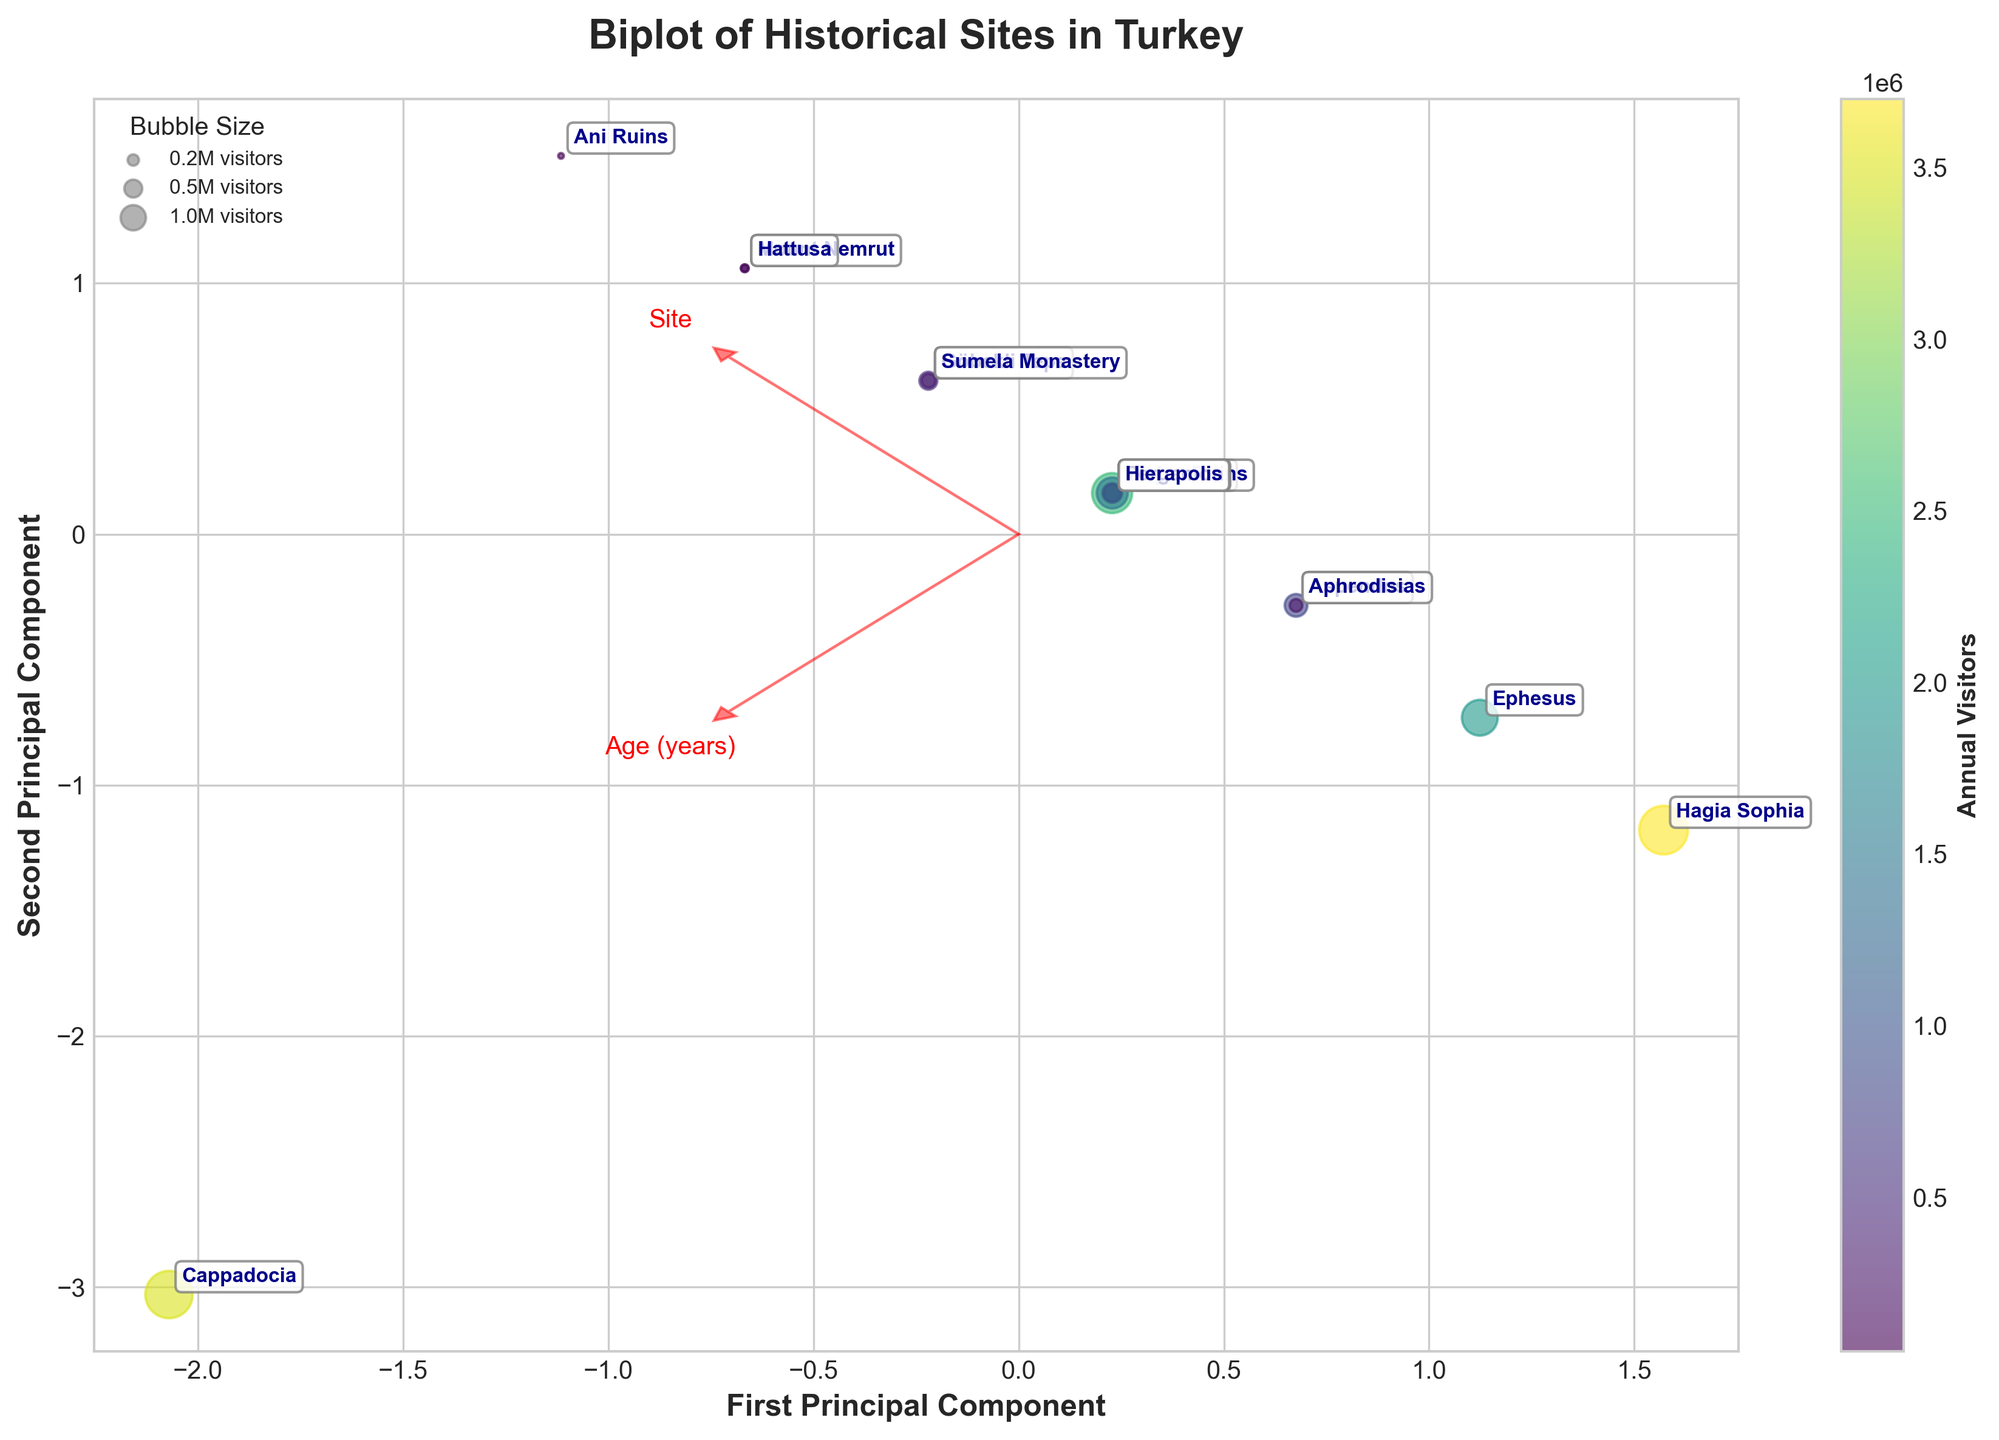How many historical sites are shown in the biplot? Count the number of distinct points labeled on the biplot. Each point represents a different historical site.
Answer: 13 What is the title of the biplot? Read the main title of the plot displayed at the top.
Answer: Biplot of Historical Sites in Turkey Which two features are represented by the red arrows in the biplot? Identify the labels associated with the red arrows. Each label corresponds to a different feature of the data.
Answer: Age (years) and Visitor Accessibility (1-10) Which historical site has the highest visitor accessibility score and where is it located in relation to the principal components? Find the site labeled with the highest value for visitor accessibility (10), and note its location on the biplot in terms of principal components.
Answer: Hagia Sophia; near the right of the first principal component Which site appears to have the oldest historical age? Look for the site that is plotted along the arrow pointing towards the highest age. Identify the corresponding label.
Answer: Cappadocia How does the visitor accessibility of Ephesus compare to that of Göbekli Tepe? Compare the positions of Ephesus and Göbekli Tepe on the biplot relative to the Visitor Accessibility arrow.
Answer: Ephesus has higher accessibility than Göbekli Tepe What is the range of annual visitors for the sites shown in the plot? Identify the site with the largest bubble and the site with the smallest bubble. Read the colorbar to find the range of their annual visitors.
Answer: From 50,000 (Ani Ruins) to 3,700,000 (Hagia Sophia) Which site has the lowest visitor accessibility and where is it located in the principal components? Identify the site with the smallest visitor accessibility value and note its position on the biplot.
Answer: Ani Ruins; located towards the lower portions of the second principal component What can be inferred about the correlation between visitor accessibility and annual visitors based on the biplot? Assess the general trend of how points are distributed along the Visitor Accessibility axis and the size and color of the bubbles.
Answer: There is a positive correlation; higher accessibility tends to correspond with more annual visitors Which feature (age or accessibility) is more influential in the first principal component? Observe the direction and magnitude of the red arrows relative to the first principal component.
Answer: Visitor Accessibility 